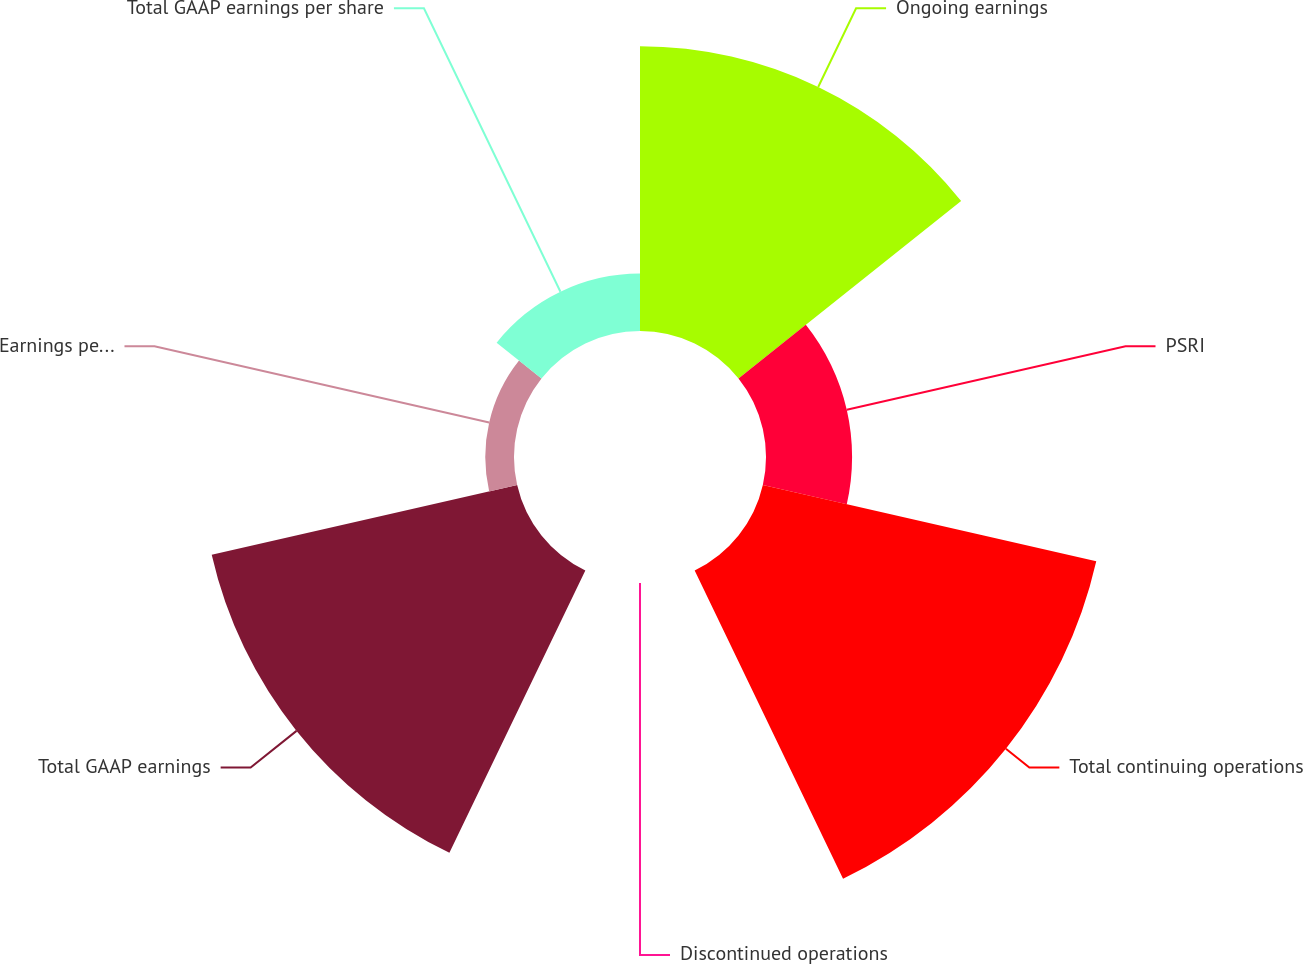<chart> <loc_0><loc_0><loc_500><loc_500><pie_chart><fcel>Ongoing earnings<fcel>PSRI<fcel>Total continuing operations<fcel>Discontinued operations<fcel>Total GAAP earnings<fcel>Earnings per share -<fcel>Total GAAP earnings per share<nl><fcel>25.6%<fcel>7.74%<fcel>30.75%<fcel>0.0%<fcel>28.17%<fcel>2.58%<fcel>5.16%<nl></chart> 